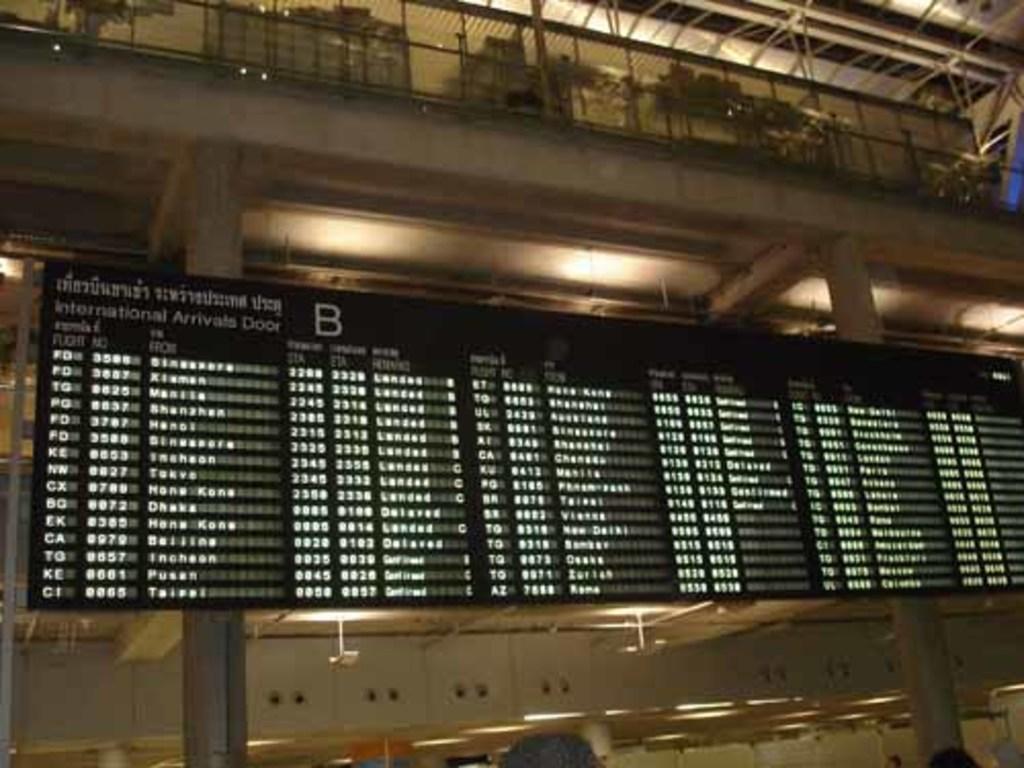Describe this image in one or two sentences. In this image we can see a black color digital board. Behind building is there and pole are there. 